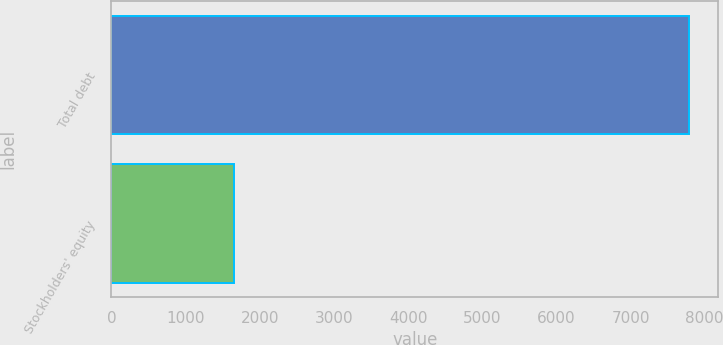Convert chart to OTSL. <chart><loc_0><loc_0><loc_500><loc_500><bar_chart><fcel>Total debt<fcel>Stockholders' equity<nl><fcel>7790<fcel>1648<nl></chart> 